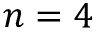<formula> <loc_0><loc_0><loc_500><loc_500>n = 4</formula> 